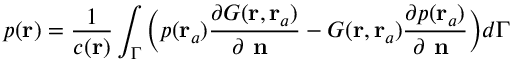<formula> <loc_0><loc_0><loc_500><loc_500>p ( r ) = \frac { 1 } { c ( r ) } \int _ { \Gamma } \left ( p ( r _ { a } ) \frac { \partial G ( r , r _ { a } ) } { \partial n } - G ( r , r _ { a } ) \frac { \partial p ( r _ { a } ) } { \partial n } \right ) d \Gamma</formula> 